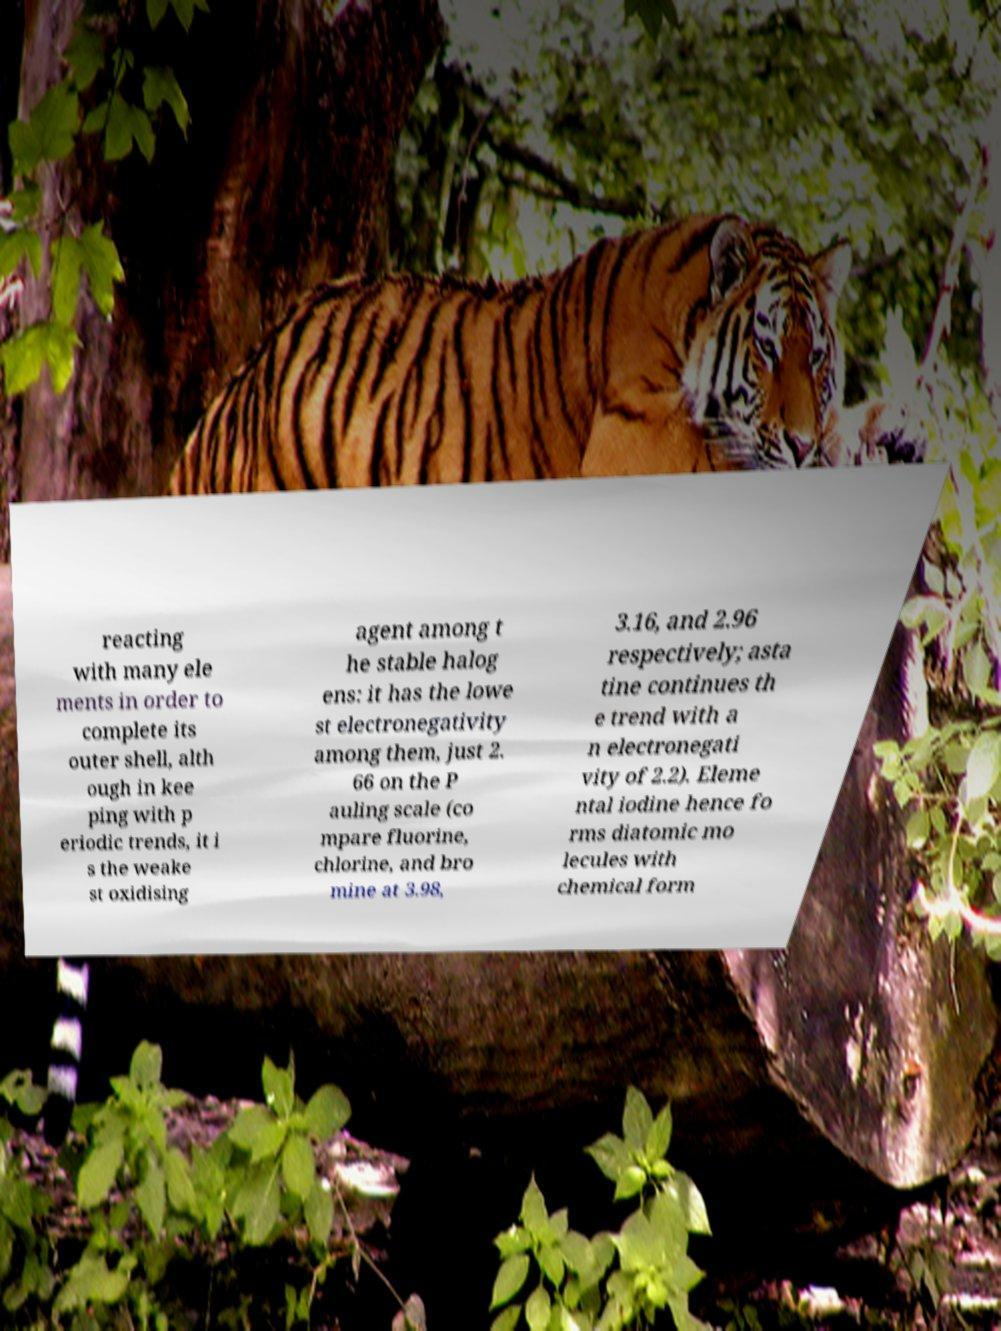Could you assist in decoding the text presented in this image and type it out clearly? reacting with many ele ments in order to complete its outer shell, alth ough in kee ping with p eriodic trends, it i s the weake st oxidising agent among t he stable halog ens: it has the lowe st electronegativity among them, just 2. 66 on the P auling scale (co mpare fluorine, chlorine, and bro mine at 3.98, 3.16, and 2.96 respectively; asta tine continues th e trend with a n electronegati vity of 2.2). Eleme ntal iodine hence fo rms diatomic mo lecules with chemical form 